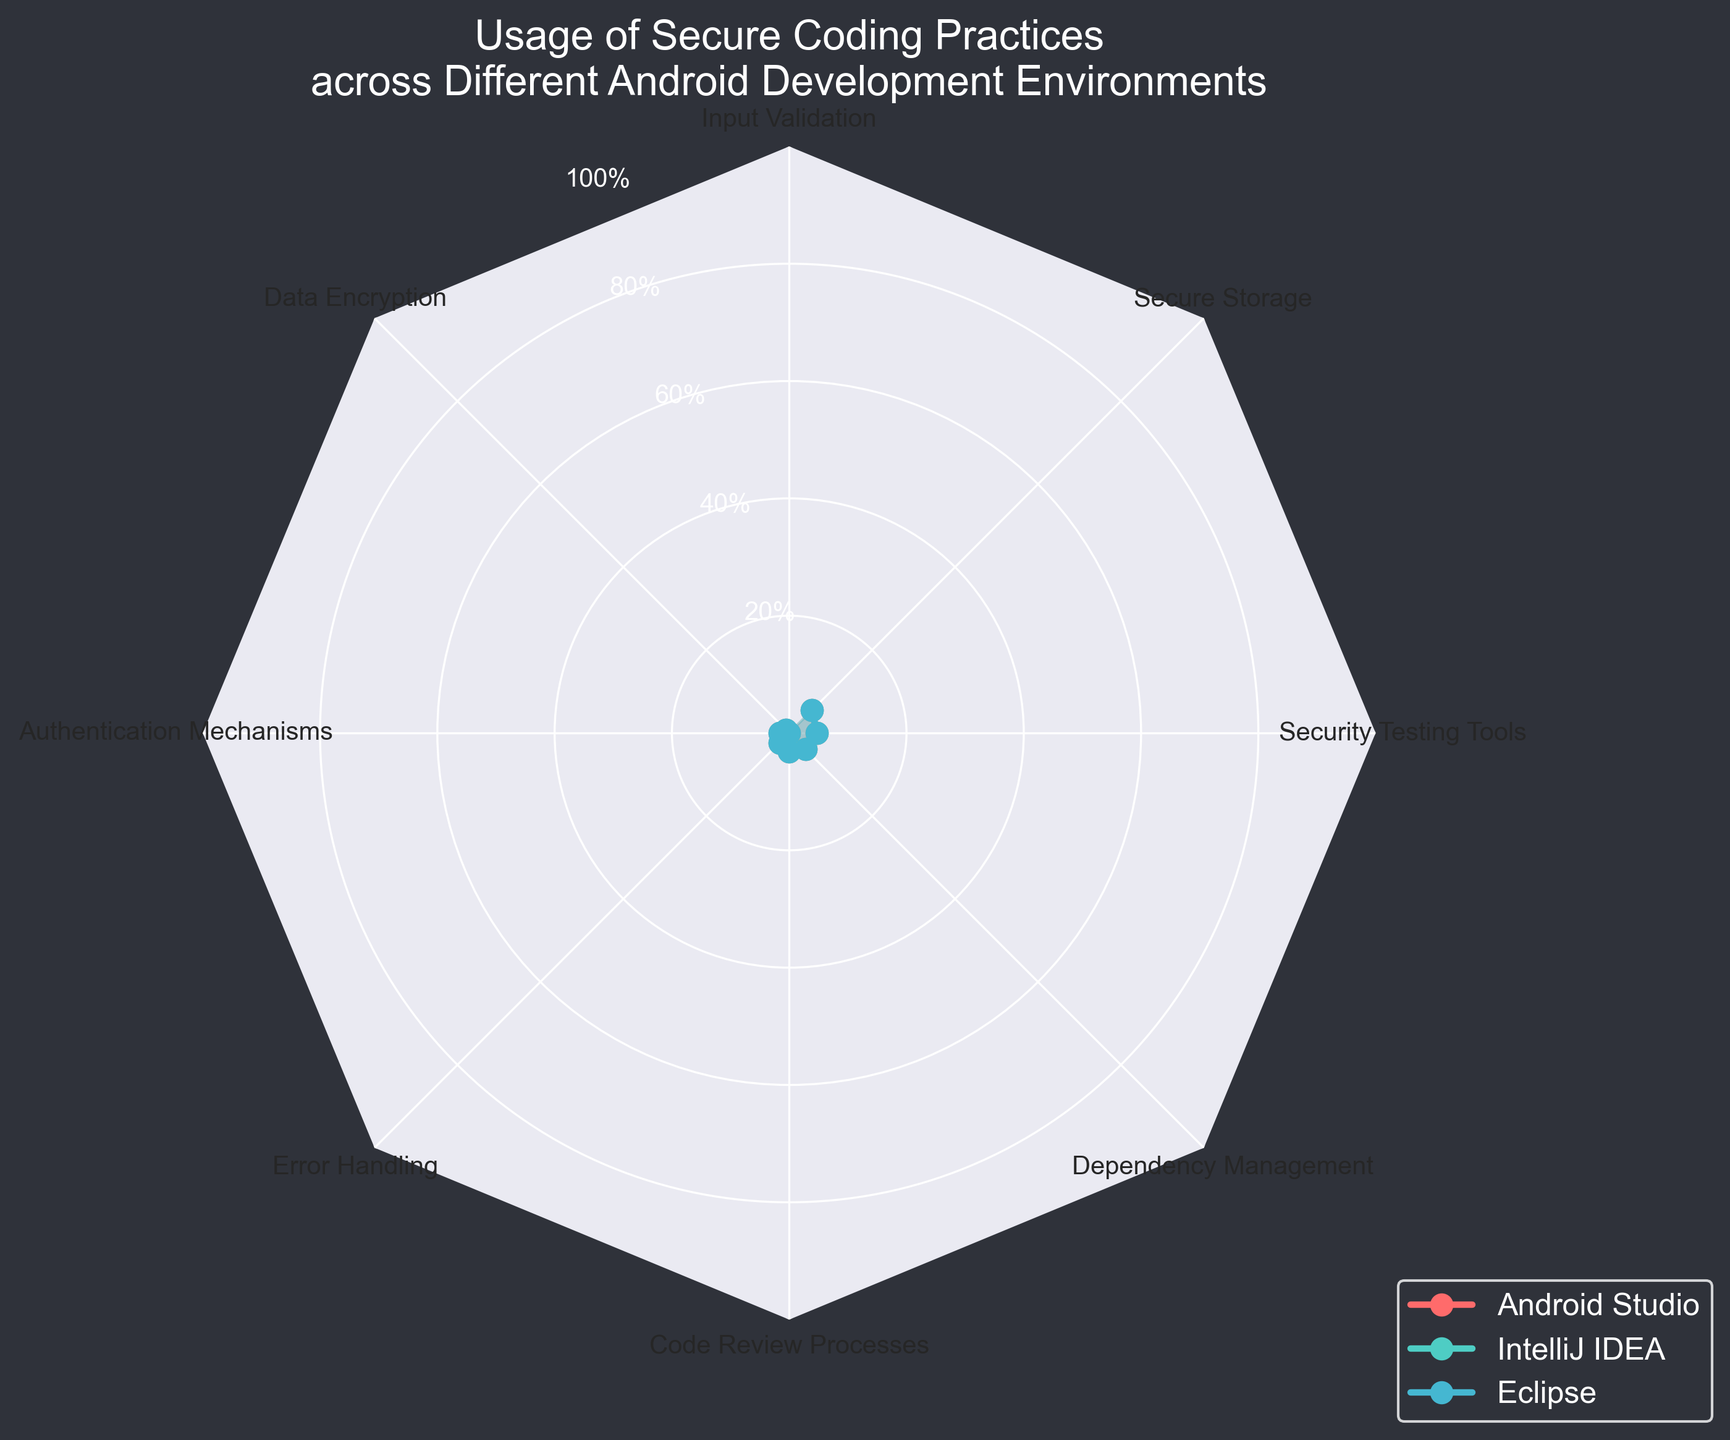What's the title of the figure? The title is displayed at the top of the figure, reading "Usage of Secure Coding Practices across Different Android Development Environments".
Answer: Usage of Secure Coding Practices across Different Android Development Environments What are the three environments compared in the figure? By observing the legend in the figure, we can see the three environments listed as "Android Studio", "IntelliJ IDEA", and "Eclipse".
Answer: Android Studio, IntelliJ IDEA, Eclipse Which coding practice has the highest usage percentage in Android Studio? The highest value in the Android Studio group, indicated by the red line, corresponds to "Authentication Mechanisms" with a value of 90.
Answer: Authentication Mechanisms How many different coding practices are evaluated in the figure? The number of coding practices is determined by counting the labeled categories around the circumference of the radar chart. There are 8 coding practices evaluated.
Answer: 8 Which environment has the lowest usage percentage for "Secure Storage"? The lowest point for "Secure Storage" can be identified by comparing the values at "Secure Storage". Eclipse, indicated by the blue line, has the lowest value at 60.
Answer: Eclipse What is the average usage percentage for "Error Handling" across all environments? To find the average usage percentage for "Error Handling", add the percentages for "Error Handling" from each environment (80 + 75 + 60) and then divide by 3. Therefore, (80 + 75 + 60) / 3 = 71.67%
Answer: 71.67% Which coding practice shows the largest difference in usage between Android Studio and Eclipse? To determine this, calculate the difference in usage for each coding practice: Input Validation (75-60=15), Data Encryption (85-65=20), Authentication Mechanisms (90-70=20), Error Handling (80-60=20), Code Review Processes (70-55=15), Dependency Management (65-50=15), Security Testing Tools (75-55=20), Secure Storage (80-60=20). The largest difference is 20 for "Data Encryption", "Authentication Mechanisms", "Error Handling", "Security Testing Tools", and "Secure Storage".
Answer: Data Encryption, Authentication Mechanisms, Error Handling, Security Testing Tools, Secure Storage Which coding practice has a consistent trend across all environments? Assessing the graph, "Dependency Management" shows a consistent trend where the usage tends to decrease uniformly from Android Studio to IntelliJ IDEA to Eclipse.
Answer: Dependency Management Between Android Studio and IntelliJ IDEA, which environment has higher overall scores for secure coding practices? By visually comparing the two lines, the red line representing Android Studio consistently has higher or equal values compared to the green line representing IntelliJ IDEA for most coding practices.
Answer: Android Studio 